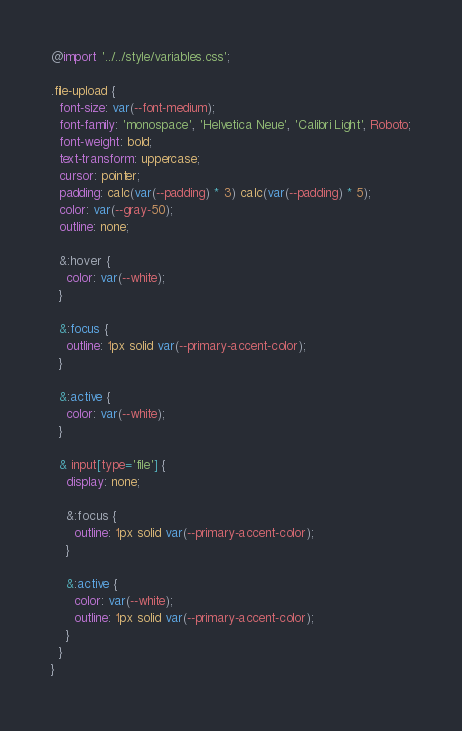Convert code to text. <code><loc_0><loc_0><loc_500><loc_500><_CSS_>@import '../../style/variables.css';

.file-upload {
  font-size: var(--font-medium);
  font-family: 'monospace', 'Helvetica Neue', 'Calibri Light', Roboto;
  font-weight: bold;
  text-transform: uppercase;
  cursor: pointer;
  padding: calc(var(--padding) * 3) calc(var(--padding) * 5);
  color: var(--gray-50);
  outline: none;

  &:hover {
    color: var(--white);
  }

  &:focus {
    outline: 1px solid var(--primary-accent-color);
  }

  &:active {
    color: var(--white);
  }

  & input[type='file'] {
    display: none;

    &:focus {
      outline: 1px solid var(--primary-accent-color);
    }

    &:active {
      color: var(--white);
      outline: 1px solid var(--primary-accent-color);
    }
  }
}
</code> 